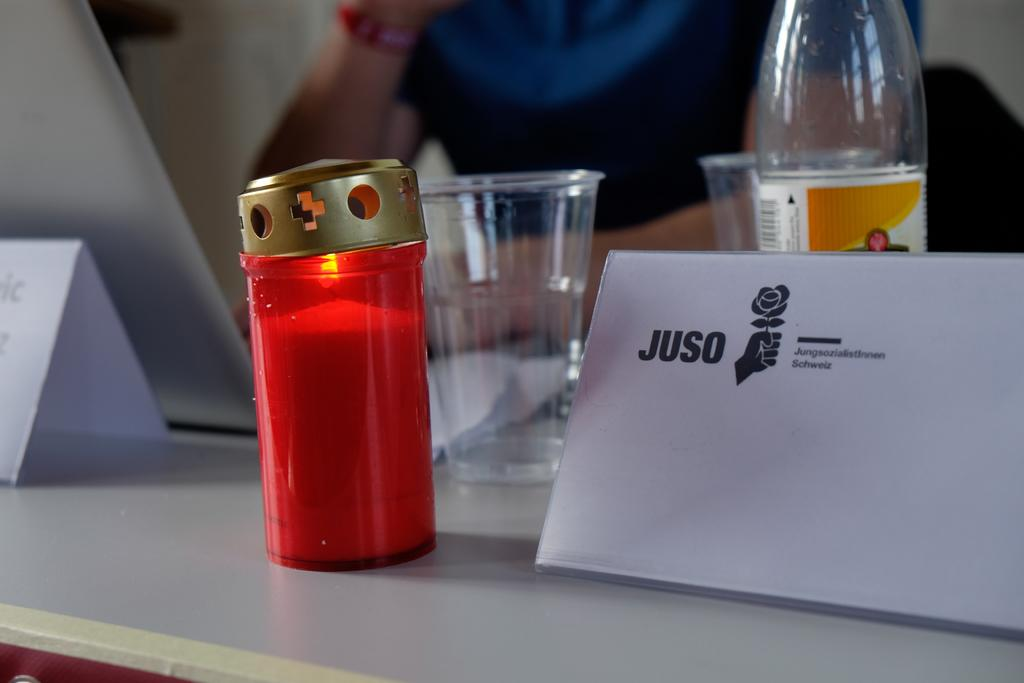<image>
Create a compact narrative representing the image presented. An envelope has the word "Juso" on it and a picture of a hand holding a flower. 